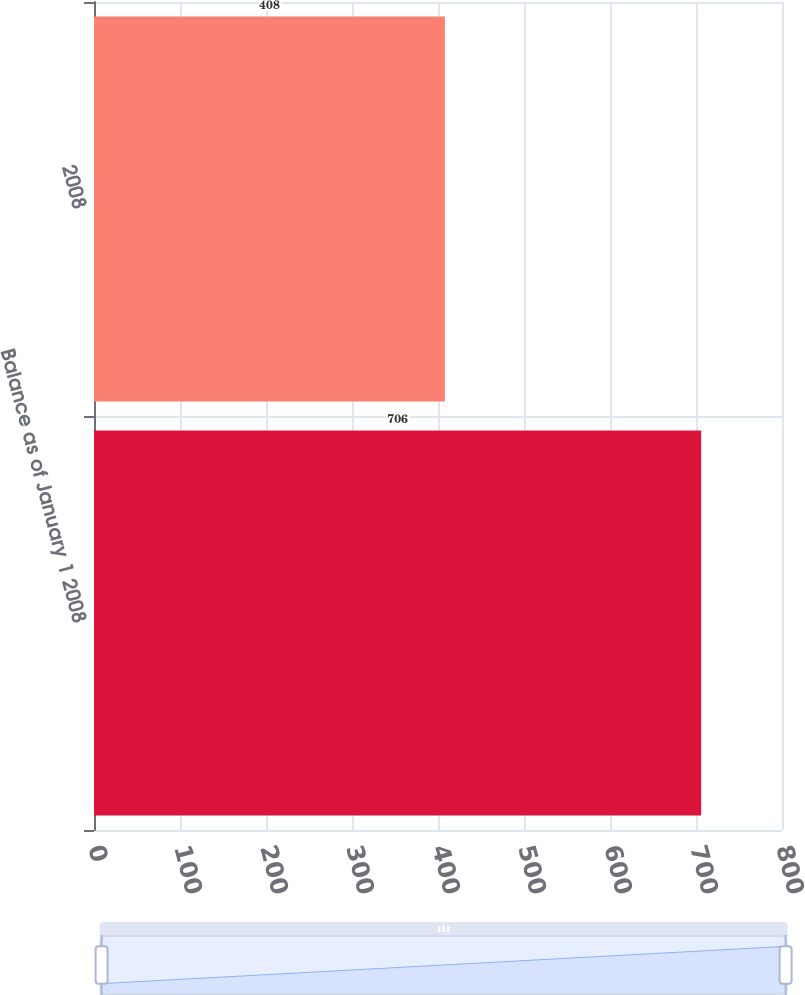<chart> <loc_0><loc_0><loc_500><loc_500><bar_chart><fcel>Balance as of January 1 2008<fcel>2008<nl><fcel>706<fcel>408<nl></chart> 